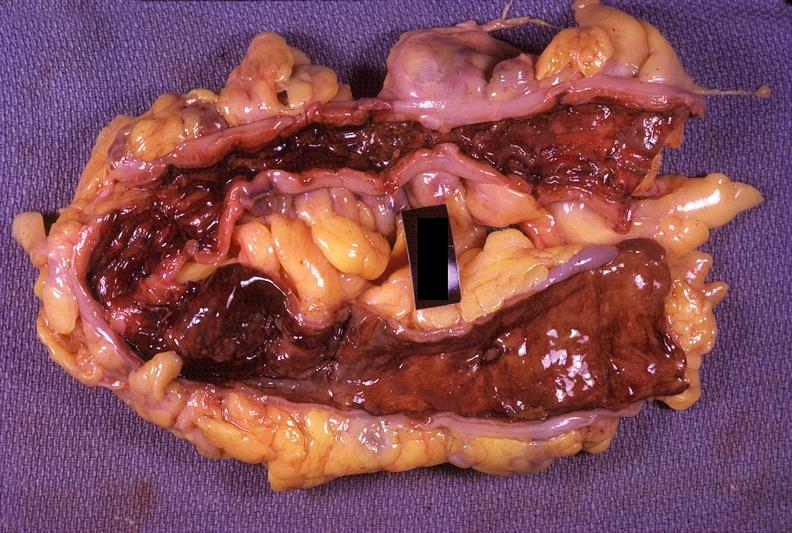what does this image show?
Answer the question using a single word or phrase. Colon 